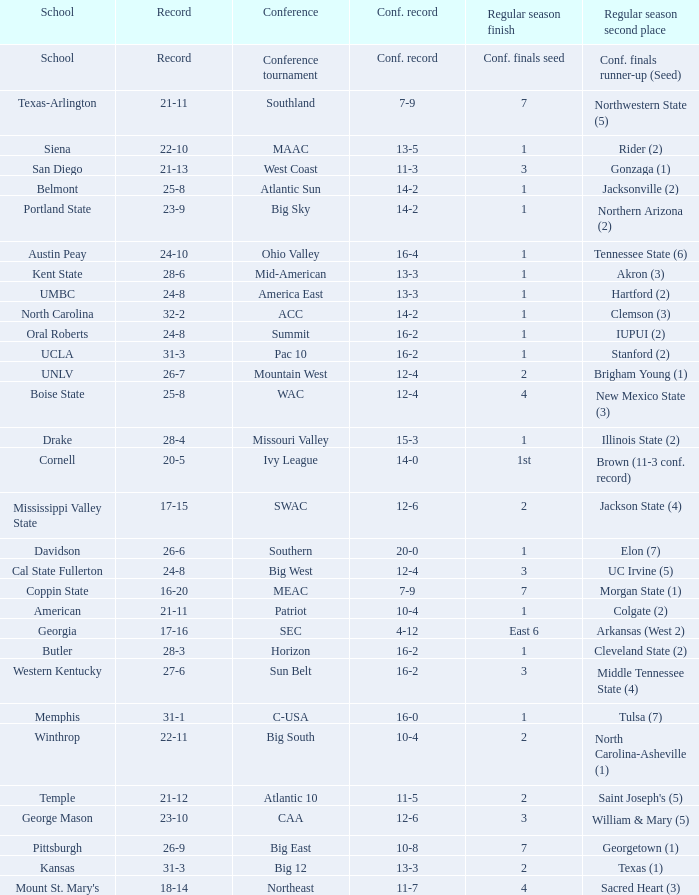Which qualifying schools were in the Patriot conference? American. 